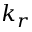<formula> <loc_0><loc_0><loc_500><loc_500>k _ { r }</formula> 